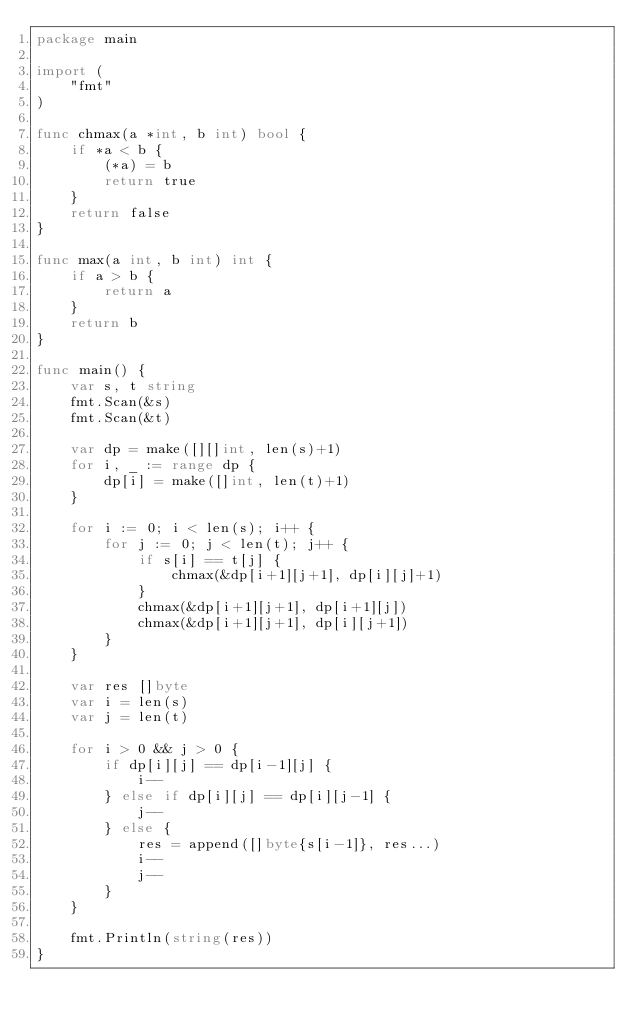Convert code to text. <code><loc_0><loc_0><loc_500><loc_500><_Go_>package main

import (
	"fmt"
)

func chmax(a *int, b int) bool {
	if *a < b {
		(*a) = b
		return true
	}
	return false
}

func max(a int, b int) int {
	if a > b {
		return a
	}
	return b
}

func main() {
	var s, t string
	fmt.Scan(&s)
	fmt.Scan(&t)

	var dp = make([][]int, len(s)+1)
	for i, _ := range dp {
		dp[i] = make([]int, len(t)+1)
	}

	for i := 0; i < len(s); i++ {
		for j := 0; j < len(t); j++ {
			if s[i] == t[j] {
				chmax(&dp[i+1][j+1], dp[i][j]+1)
			}
			chmax(&dp[i+1][j+1], dp[i+1][j])
			chmax(&dp[i+1][j+1], dp[i][j+1])
		}
	}

	var res []byte
	var i = len(s)
	var j = len(t)

	for i > 0 && j > 0 {
		if dp[i][j] == dp[i-1][j] {
			i--
		} else if dp[i][j] == dp[i][j-1] {
			j--
		} else {
			res = append([]byte{s[i-1]}, res...)
			i--
			j--
		}
	}

	fmt.Println(string(res))
}</code> 